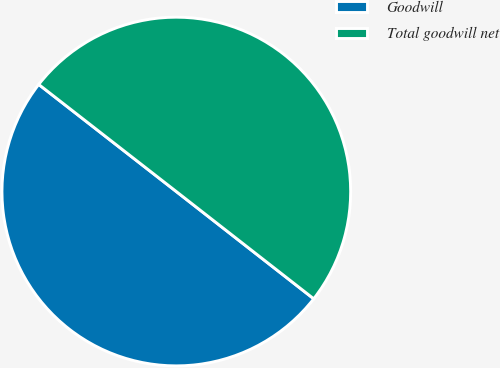Convert chart. <chart><loc_0><loc_0><loc_500><loc_500><pie_chart><fcel>Goodwill<fcel>Total goodwill net<nl><fcel>49.98%<fcel>50.02%<nl></chart> 